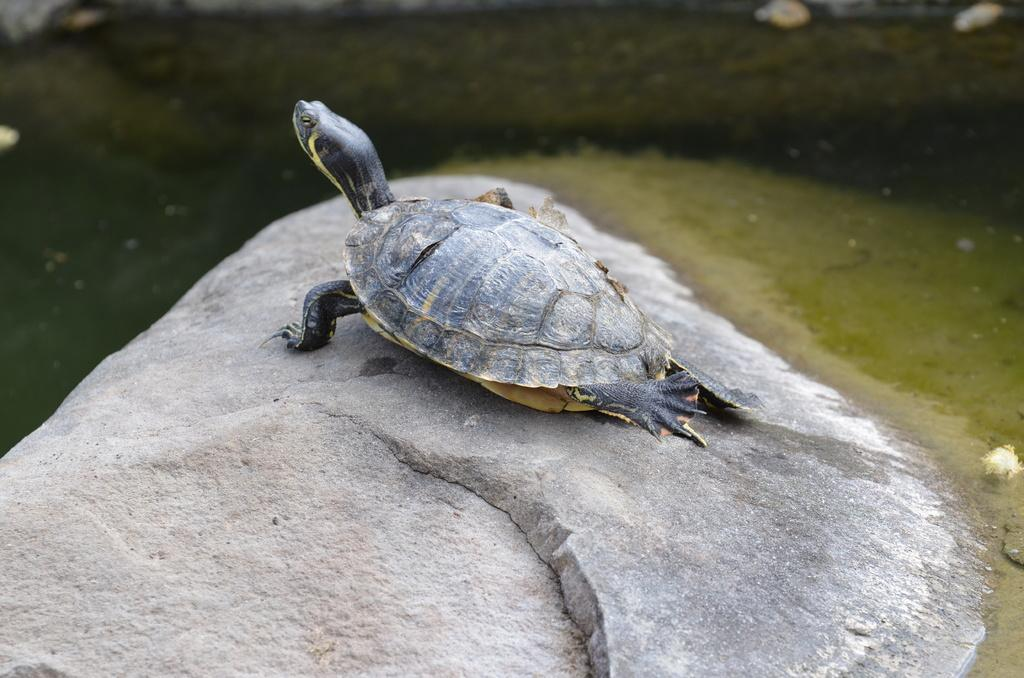What is located in the water in the image? There is a rock in the water in the image. What animal can be seen in the middle of the image? There is a turtle in the middle of the image. What type of sugar is being harvested by the farmer in the image? There is no farmer or sugar present in the image; it features a rock and a turtle in a water setting. What organization is responsible for the turtle's well-being in the image? There is no organization mentioned or implied in the image; it simply shows a turtle in the water. 